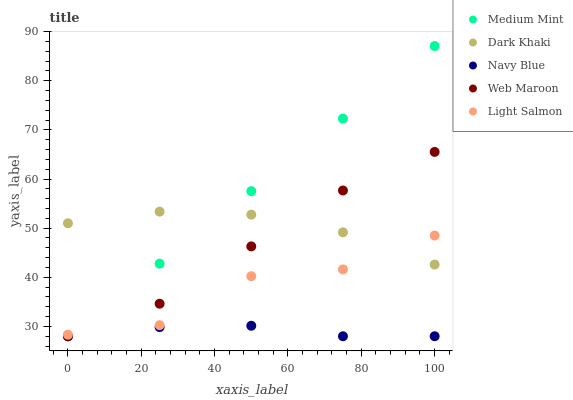Does Navy Blue have the minimum area under the curve?
Answer yes or no. Yes. Does Medium Mint have the maximum area under the curve?
Answer yes or no. Yes. Does Dark Khaki have the minimum area under the curve?
Answer yes or no. No. Does Dark Khaki have the maximum area under the curve?
Answer yes or no. No. Is Medium Mint the smoothest?
Answer yes or no. Yes. Is Light Salmon the roughest?
Answer yes or no. Yes. Is Dark Khaki the smoothest?
Answer yes or no. No. Is Dark Khaki the roughest?
Answer yes or no. No. Does Medium Mint have the lowest value?
Answer yes or no. Yes. Does Light Salmon have the lowest value?
Answer yes or no. No. Does Medium Mint have the highest value?
Answer yes or no. Yes. Does Dark Khaki have the highest value?
Answer yes or no. No. Is Navy Blue less than Dark Khaki?
Answer yes or no. Yes. Is Dark Khaki greater than Navy Blue?
Answer yes or no. Yes. Does Medium Mint intersect Navy Blue?
Answer yes or no. Yes. Is Medium Mint less than Navy Blue?
Answer yes or no. No. Is Medium Mint greater than Navy Blue?
Answer yes or no. No. Does Navy Blue intersect Dark Khaki?
Answer yes or no. No. 